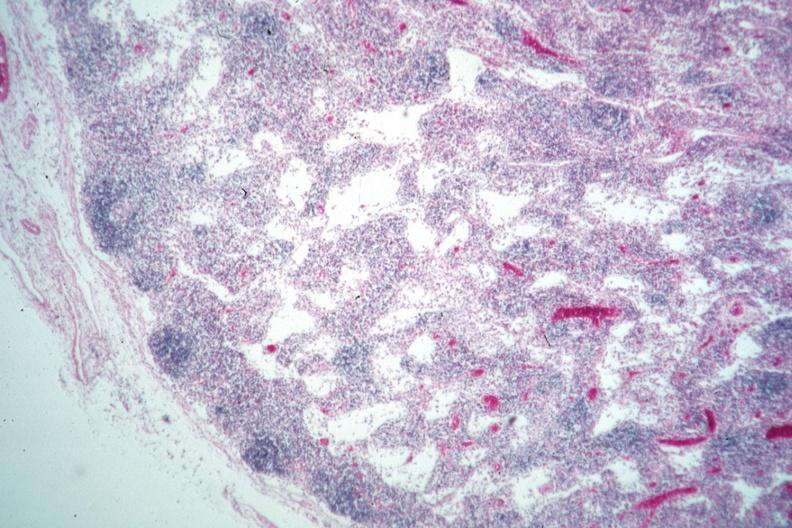how is nice example lymphocyte depleted area?
Answer the question using a single word or phrase. Medullary 